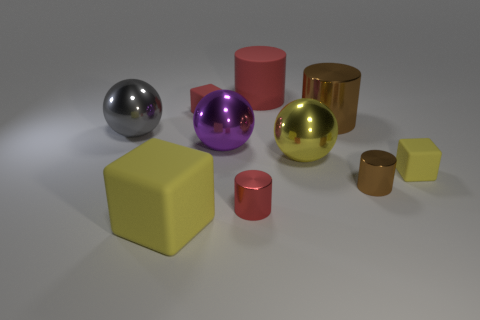Subtract all red cylinders. How many were subtracted if there are1red cylinders left? 1 Subtract 1 cylinders. How many cylinders are left? 3 Subtract all cylinders. How many objects are left? 6 Add 3 tiny cylinders. How many tiny cylinders are left? 5 Add 3 red cylinders. How many red cylinders exist? 5 Subtract 0 green balls. How many objects are left? 10 Subtract all brown cylinders. Subtract all small red cubes. How many objects are left? 7 